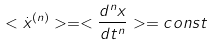Convert formula to latex. <formula><loc_0><loc_0><loc_500><loc_500>< \dot { x } ^ { ( n ) } > = < \frac { d ^ { n } x } { d t ^ { n } } > = c o n s t</formula> 